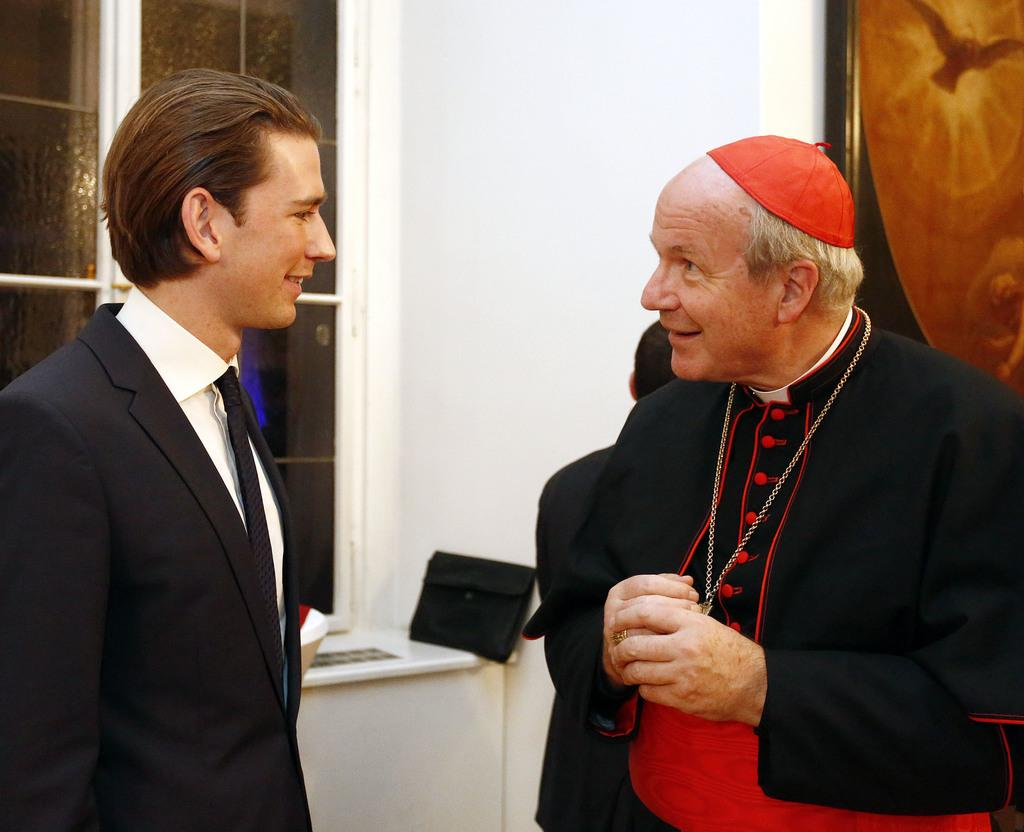What is happening in the room in the image? There are people standing in the room. What can be seen on the wall in the image? There is a photo frame on the wall. What is near the window in the image? There are objects near the window. Can you see a stick in the lawyer's hand in the image? There is no lawyer or stick present in the image. What type of tail is visible on the people in the image? There are no tails visible on the people in the image. 